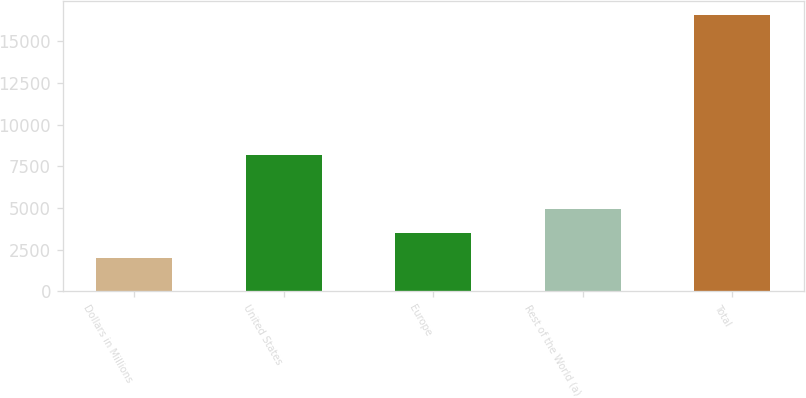Convert chart to OTSL. <chart><loc_0><loc_0><loc_500><loc_500><bar_chart><fcel>Dollars in Millions<fcel>United States<fcel>Europe<fcel>Rest of the World (a)<fcel>Total<nl><fcel>2015<fcel>8188<fcel>3491<fcel>4945.5<fcel>16560<nl></chart> 